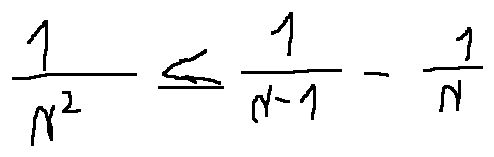<formula> <loc_0><loc_0><loc_500><loc_500>\frac { 1 } { n ^ { 2 } } \leq \frac { 1 } { n - 1 } - \frac { 1 } { n }</formula> 